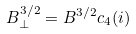<formula> <loc_0><loc_0><loc_500><loc_500>B _ { \perp } ^ { 3 / 2 } = B ^ { 3 / 2 } c _ { 4 } ( i )</formula> 